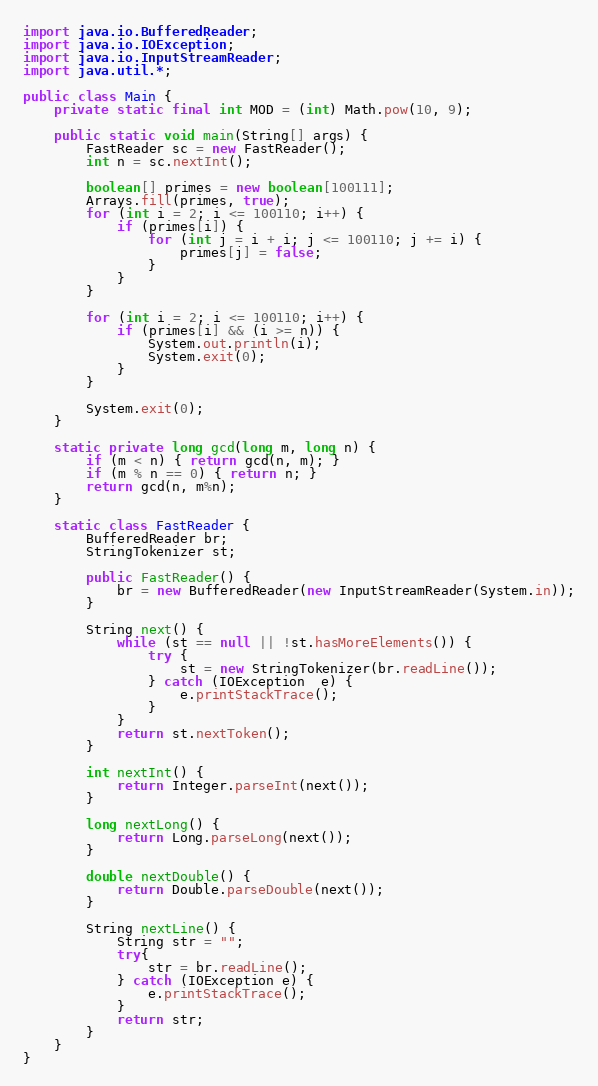<code> <loc_0><loc_0><loc_500><loc_500><_Java_>import java.io.BufferedReader;
import java.io.IOException;
import java.io.InputStreamReader;
import java.util.*;

public class Main {
    private static final int MOD = (int) Math.pow(10, 9);

    public static void main(String[] args) {
        FastReader sc = new FastReader();
        int n = sc.nextInt();

        boolean[] primes = new boolean[100111];
        Arrays.fill(primes, true);
        for (int i = 2; i <= 100110; i++) {
            if (primes[i]) {
                for (int j = i + i; j <= 100110; j += i) {
                    primes[j] = false;
                }
            }
        }

        for (int i = 2; i <= 100110; i++) {
            if (primes[i] && (i >= n)) {
                System.out.println(i);
                System.exit(0);
            }
        }

        System.exit(0);
    }

    static private long gcd(long m, long n) {
        if (m < n) { return gcd(n, m); }
        if (m % n == 0) { return n; }
        return gcd(n, m%n);
    }

    static class FastReader {
        BufferedReader br;
        StringTokenizer st;

        public FastReader() {
            br = new BufferedReader(new InputStreamReader(System.in));
        }

        String next() {
            while (st == null || !st.hasMoreElements()) {
                try {
                    st = new StringTokenizer(br.readLine());
                } catch (IOException  e) {
                    e.printStackTrace();
                }
            }
            return st.nextToken();
        }

        int nextInt() {
            return Integer.parseInt(next());
        }

        long nextLong() {
            return Long.parseLong(next());
        }

        double nextDouble() {
            return Double.parseDouble(next());
        }

        String nextLine() {
            String str = "";
            try{
                str = br.readLine();
            } catch (IOException e) {
                e.printStackTrace();
            }
            return str;
        }
    }
}
</code> 